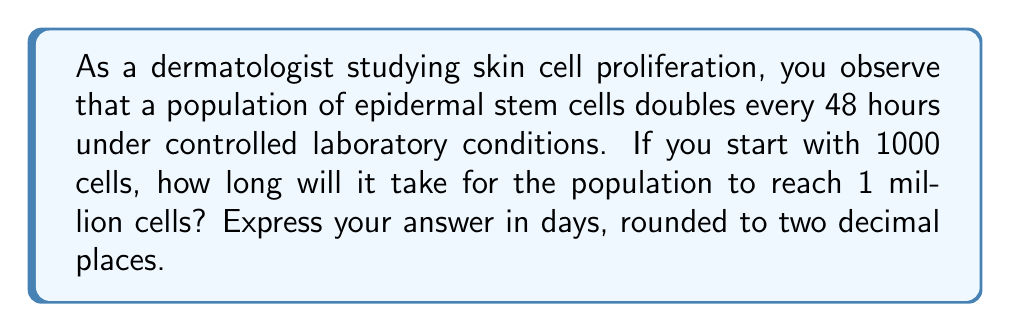Could you help me with this problem? Let's approach this step-by-step using exponential and logarithmic functions:

1) Let $N(t)$ be the number of cells at time $t$ (in days), and $N_0$ be the initial number of cells.

2) The exponential growth model is given by:
   $N(t) = N_0 \cdot 2^{t/T}$
   where $T$ is the doubling time in days.

3) We're given:
   $N_0 = 1000$ cells
   $T = 48$ hours = 2 days
   We need to find $t$ when $N(t) = 1,000,000$ cells

4) Substituting into our equation:
   $1,000,000 = 1000 \cdot 2^{t/2}$

5) Dividing both sides by 1000:
   $1000 = 2^{t/2}$

6) Taking the logarithm (base 2) of both sides:
   $\log_2(1000) = \log_2(2^{t/2}) = \frac{t}{2}$

7) Solving for $t$:
   $t = 2 \cdot \log_2(1000)$

8) We can change this to natural log:
   $t = 2 \cdot \frac{\ln(1000)}{\ln(2)}$

9) Calculating:
   $t = 2 \cdot \frac{6.90775527}{0.69314718} \approx 19.93$ days

10) Rounding to two decimal places: 19.93 days
Answer: 19.93 days 